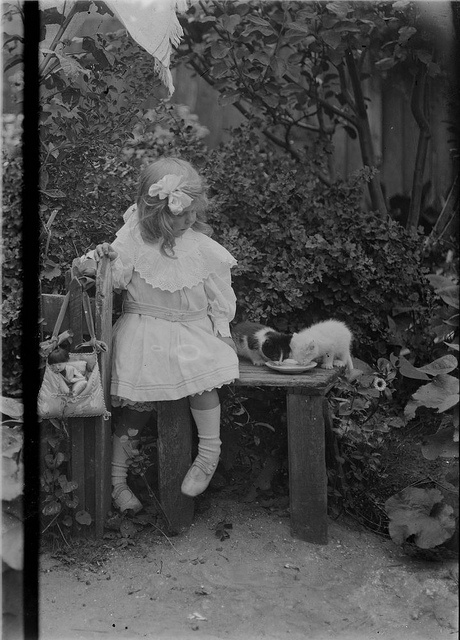Describe the objects in this image and their specific colors. I can see people in lightgray, darkgray, gray, and black tones, bench in black, gray, and lightgray tones, handbag in lightgray, gray, and black tones, cat in gray, black, lightgray, and darkgray tones, and cat in black, gray, darkgray, and lightgray tones in this image. 